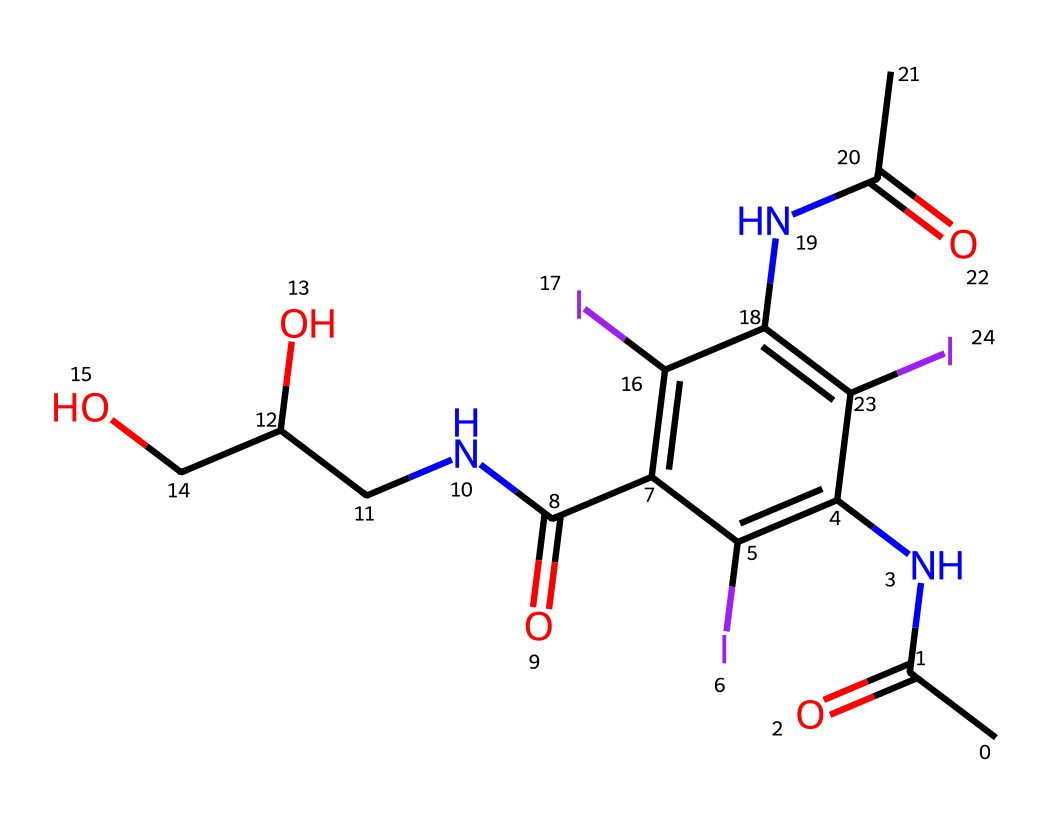What is the molecular formula of this chemical? To find the molecular formula, count the number of each type of atom present in the SMILES structure. The breakdown shows 14 Carbon (C), 16 Hydrogen (H), 4 Nitrogen (N), 4 Oxygen (O), and 3 Iodine (I) atoms. Therefore, the molecular formula is C14H16N4O4I3.
Answer: C14H16N4O4I3 How many rings are present in this chemical structure? Examine the chemical structure represented in the SMILES notation. The presence of cyclic structures can be identified by the use of 'C1' to denote the start and finish of a ring. There is only one ring in this structure, as indicated by only one 'C1' occurrence.
Answer: 1 What gives the contrast agent its imaging properties? The imaging properties are typically due to the presence of heavy atoms, such as iodine in this case, which increase the contrast between different tissues in medical imaging. The three iodine (I) atoms contribute significantly to the agent's effectiveness.
Answer: Iodine What is the functional group present at the acetyl part of the structure? The acetyl group is represented by the ‘CC(=O)’ part of the SMILES, which indicates a carbonyl (C=O) bonded to a methyl group (CH3), making it a carbonyl functional group.
Answer: Carbonyl How many nitrogen atoms are present in the chemical structure? To find the number of nitrogen atoms, scan through the SMILES representation looking for 'N'. This chemical has a total of four nitrogen (N) atoms as denoted in the structure.
Answer: 4 Are there any hydroxyl groups in this compound? The presence of a hydroxyl group (–OH) indicates the presence of a functional group that can be found in the structure. The 'CC(O)' portion clearly indicates the presence of at least one hydroxyl group in the molecule.
Answer: Yes 